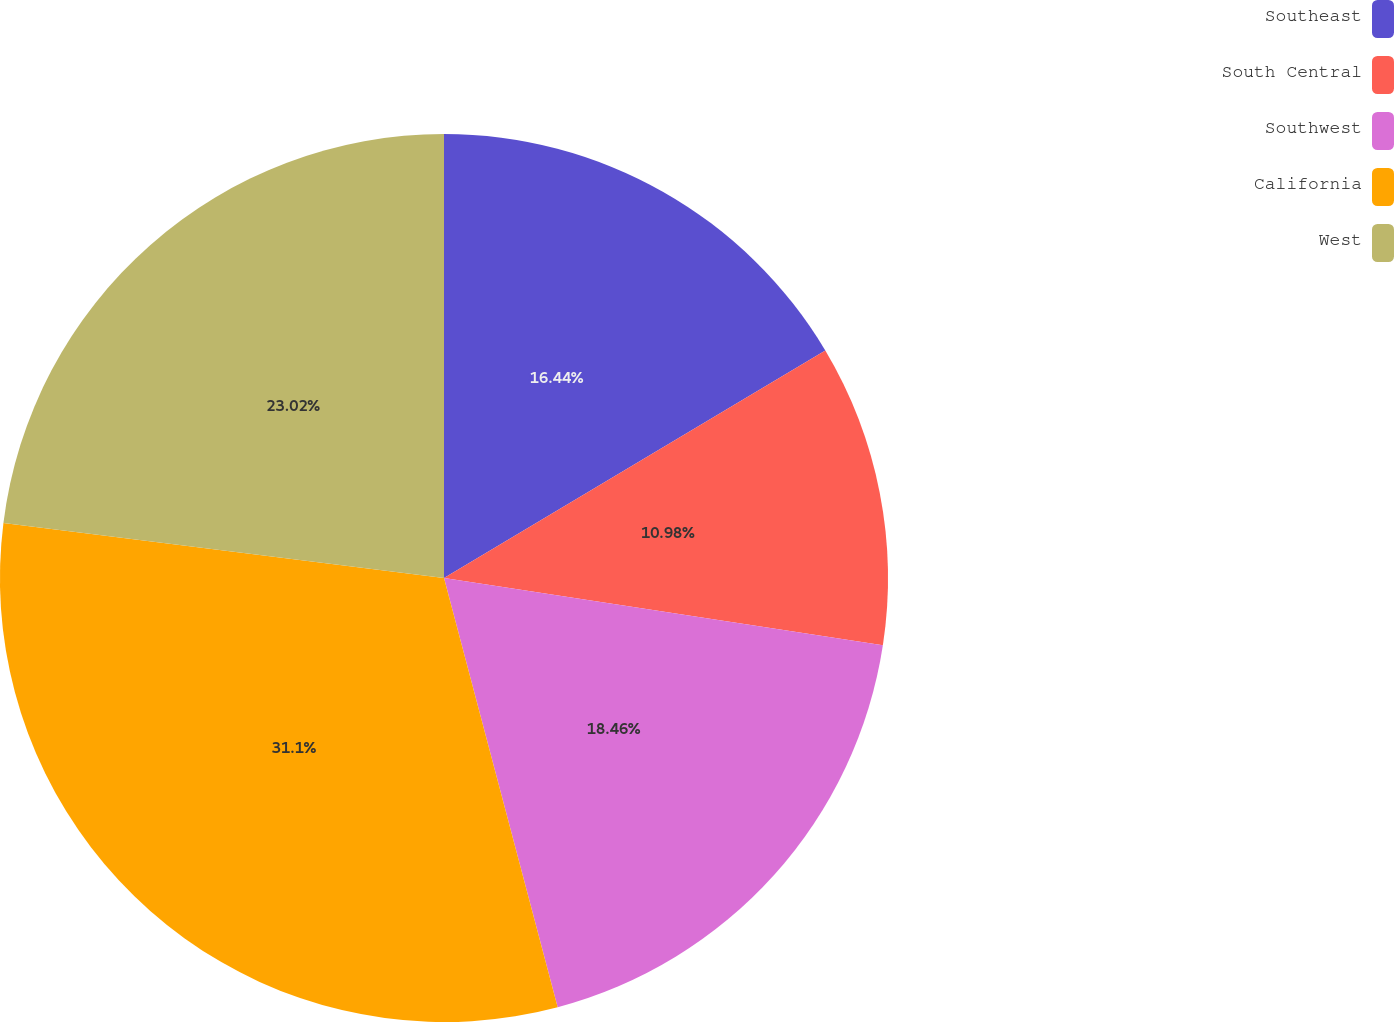<chart> <loc_0><loc_0><loc_500><loc_500><pie_chart><fcel>Southeast<fcel>South Central<fcel>Southwest<fcel>California<fcel>West<nl><fcel>16.44%<fcel>10.98%<fcel>18.46%<fcel>31.1%<fcel>23.02%<nl></chart> 